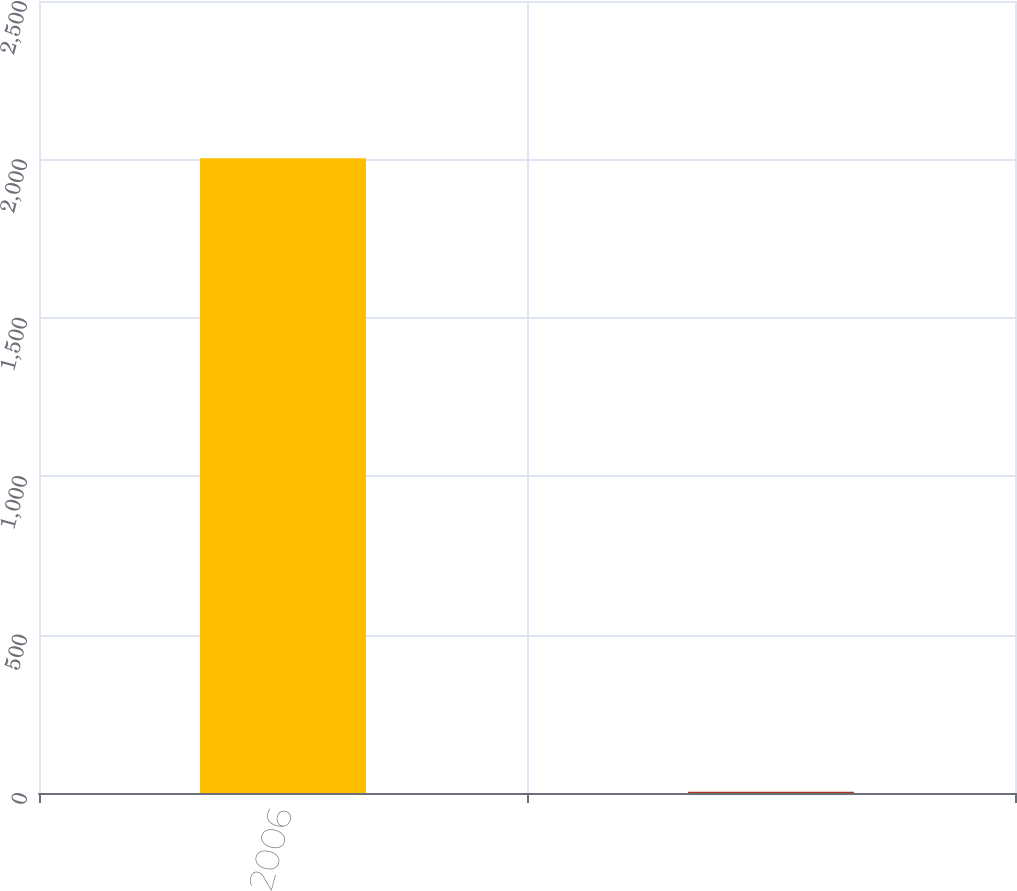Convert chart. <chart><loc_0><loc_0><loc_500><loc_500><bar_chart><fcel>2006<fcel>Unnamed: 1<nl><fcel>2004<fcel>4<nl></chart> 